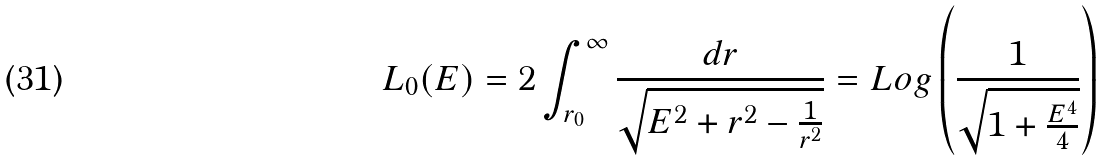<formula> <loc_0><loc_0><loc_500><loc_500>L _ { 0 } ( E ) = 2 \int _ { r _ { 0 } } ^ { \infty } \frac { d r } { \sqrt { E ^ { 2 } + r ^ { 2 } - \frac { 1 } { r ^ { 2 } } } } = L o g \left ( \frac { 1 } { \sqrt { 1 + \frac { E ^ { 4 } } { 4 } } } \right )</formula> 